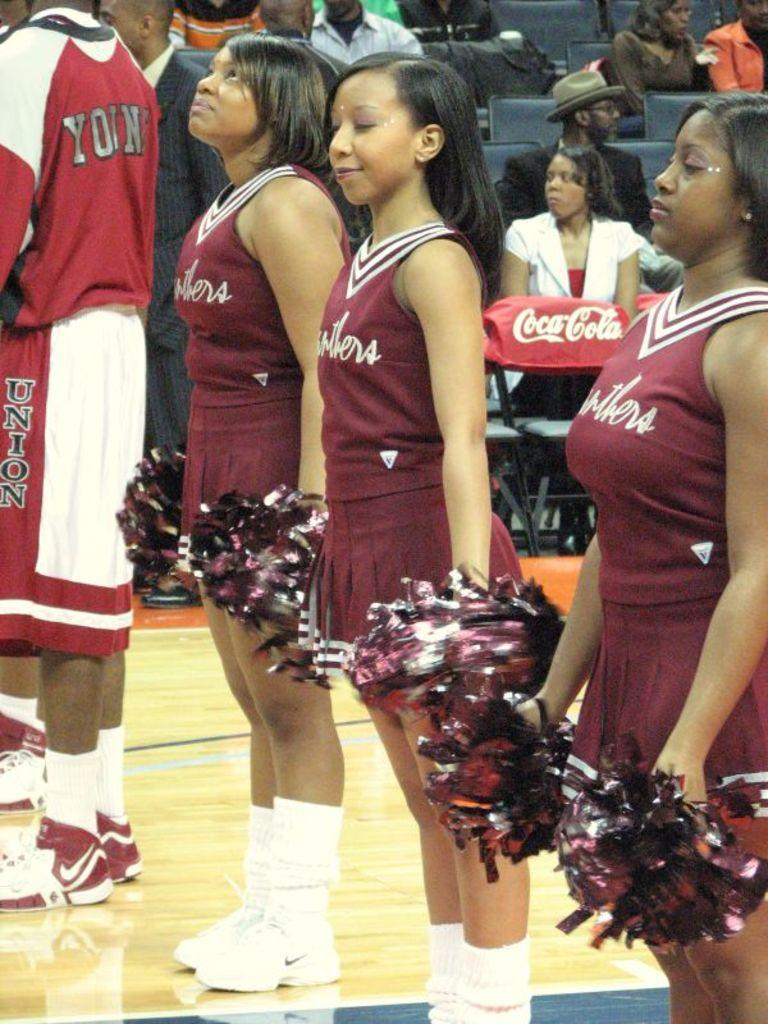<image>
Share a concise interpretation of the image provided. A player whose shorts say Union on the side stands near a group of cheerleaders. 